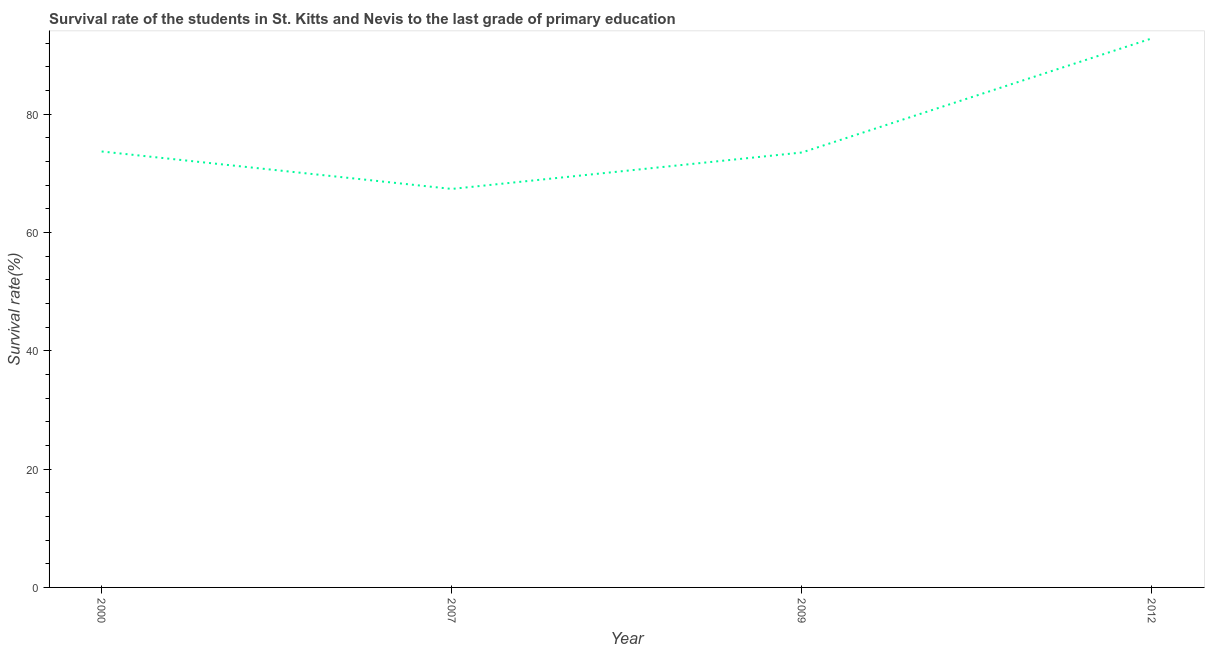What is the survival rate in primary education in 2000?
Offer a terse response. 73.7. Across all years, what is the maximum survival rate in primary education?
Your answer should be very brief. 92.82. Across all years, what is the minimum survival rate in primary education?
Provide a succinct answer. 67.37. In which year was the survival rate in primary education minimum?
Your answer should be compact. 2007. What is the sum of the survival rate in primary education?
Give a very brief answer. 307.41. What is the difference between the survival rate in primary education in 2000 and 2012?
Your answer should be compact. -19.12. What is the average survival rate in primary education per year?
Provide a succinct answer. 76.85. What is the median survival rate in primary education?
Keep it short and to the point. 73.61. In how many years, is the survival rate in primary education greater than 88 %?
Your response must be concise. 1. Do a majority of the years between 2009 and 2012 (inclusive) have survival rate in primary education greater than 12 %?
Give a very brief answer. Yes. What is the ratio of the survival rate in primary education in 2007 to that in 2009?
Provide a succinct answer. 0.92. Is the survival rate in primary education in 2000 less than that in 2007?
Give a very brief answer. No. Is the difference between the survival rate in primary education in 2000 and 2012 greater than the difference between any two years?
Provide a succinct answer. No. What is the difference between the highest and the second highest survival rate in primary education?
Your response must be concise. 19.12. Is the sum of the survival rate in primary education in 2000 and 2009 greater than the maximum survival rate in primary education across all years?
Keep it short and to the point. Yes. What is the difference between the highest and the lowest survival rate in primary education?
Make the answer very short. 25.46. How many years are there in the graph?
Offer a very short reply. 4. Are the values on the major ticks of Y-axis written in scientific E-notation?
Give a very brief answer. No. Does the graph contain grids?
Offer a terse response. No. What is the title of the graph?
Ensure brevity in your answer.  Survival rate of the students in St. Kitts and Nevis to the last grade of primary education. What is the label or title of the Y-axis?
Provide a succinct answer. Survival rate(%). What is the Survival rate(%) of 2000?
Ensure brevity in your answer.  73.7. What is the Survival rate(%) in 2007?
Provide a succinct answer. 67.37. What is the Survival rate(%) in 2009?
Your response must be concise. 73.53. What is the Survival rate(%) in 2012?
Make the answer very short. 92.82. What is the difference between the Survival rate(%) in 2000 and 2007?
Keep it short and to the point. 6.33. What is the difference between the Survival rate(%) in 2000 and 2009?
Keep it short and to the point. 0.17. What is the difference between the Survival rate(%) in 2000 and 2012?
Your answer should be compact. -19.12. What is the difference between the Survival rate(%) in 2007 and 2009?
Ensure brevity in your answer.  -6.16. What is the difference between the Survival rate(%) in 2007 and 2012?
Offer a terse response. -25.46. What is the difference between the Survival rate(%) in 2009 and 2012?
Offer a very short reply. -19.3. What is the ratio of the Survival rate(%) in 2000 to that in 2007?
Give a very brief answer. 1.09. What is the ratio of the Survival rate(%) in 2000 to that in 2012?
Offer a very short reply. 0.79. What is the ratio of the Survival rate(%) in 2007 to that in 2009?
Keep it short and to the point. 0.92. What is the ratio of the Survival rate(%) in 2007 to that in 2012?
Your answer should be compact. 0.73. What is the ratio of the Survival rate(%) in 2009 to that in 2012?
Your answer should be compact. 0.79. 